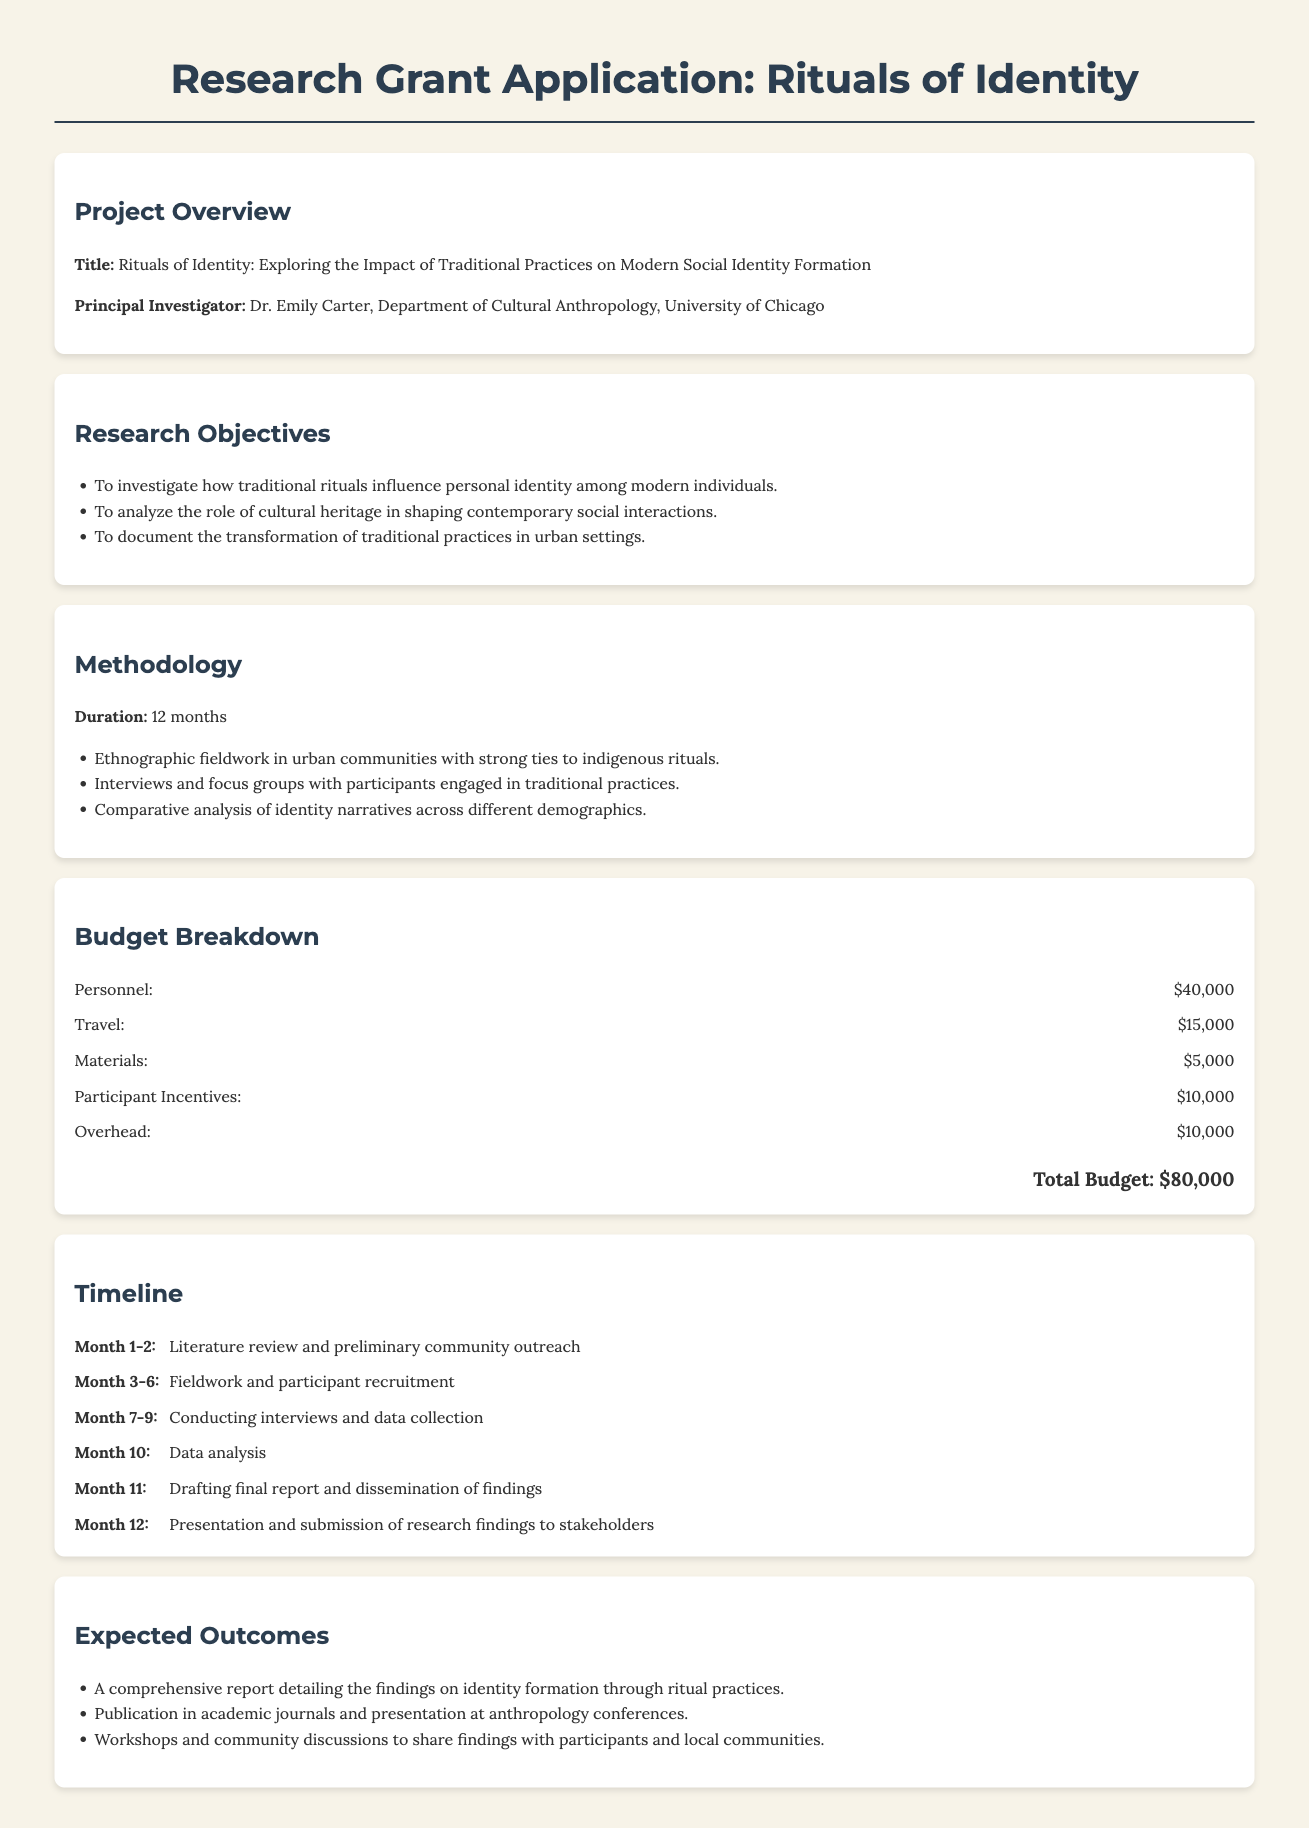what is the title of the project? The title of the project is stated in the Project Overview section.
Answer: Rituals of Identity: Exploring the Impact of Traditional Practices on Modern Social Identity Formation who is the principal investigator? The principal investigator's name is mentioned in the Project Overview section.
Answer: Dr. Emily Carter how long is the research duration? The research duration is specified in the Methodology section.
Answer: 12 months what is the budget allocated for participant incentives? The budget allocated for participant incentives is found in the Budget Breakdown section.
Answer: $10,000 what are the expected outcomes of the research? The expected outcomes are detailed in the last section of the document.
Answer: A comprehensive report detailing the findings on identity formation through ritual practices how much total budget is requested for the project? The total budget is indicated at the end of the Budget Breakdown section.
Answer: $80,000 what activities are planned for Months 1-2? The activities for Months 1-2 are listed in the Timeline section.
Answer: Literature review and preliminary community outreach what method will be used for data collection? The method for data collection is mentioned in the Methodology section.
Answer: Ethnographic fieldwork which demographic will be analyzed for identity narratives? The demographic subject to analysis is specified in the Research Objectives.
Answer: Different demographics 